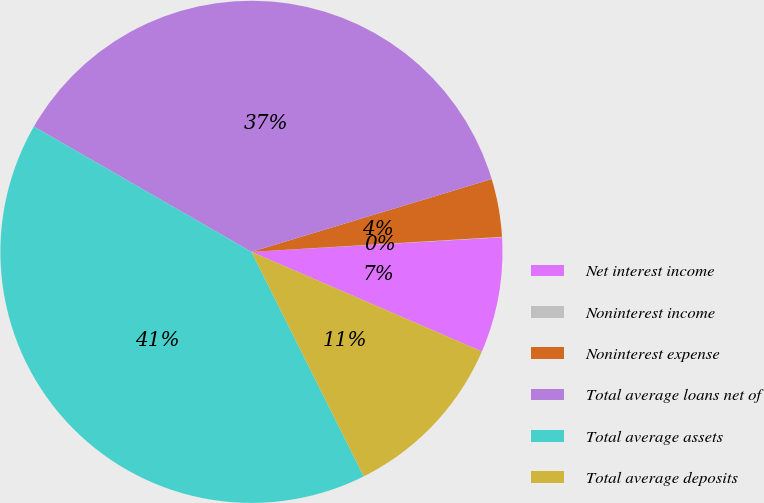Convert chart to OTSL. <chart><loc_0><loc_0><loc_500><loc_500><pie_chart><fcel>Net interest income<fcel>Noninterest income<fcel>Noninterest expense<fcel>Total average loans net of<fcel>Total average assets<fcel>Total average deposits<nl><fcel>7.42%<fcel>0.03%<fcel>3.73%<fcel>37.0%<fcel>40.7%<fcel>11.12%<nl></chart> 